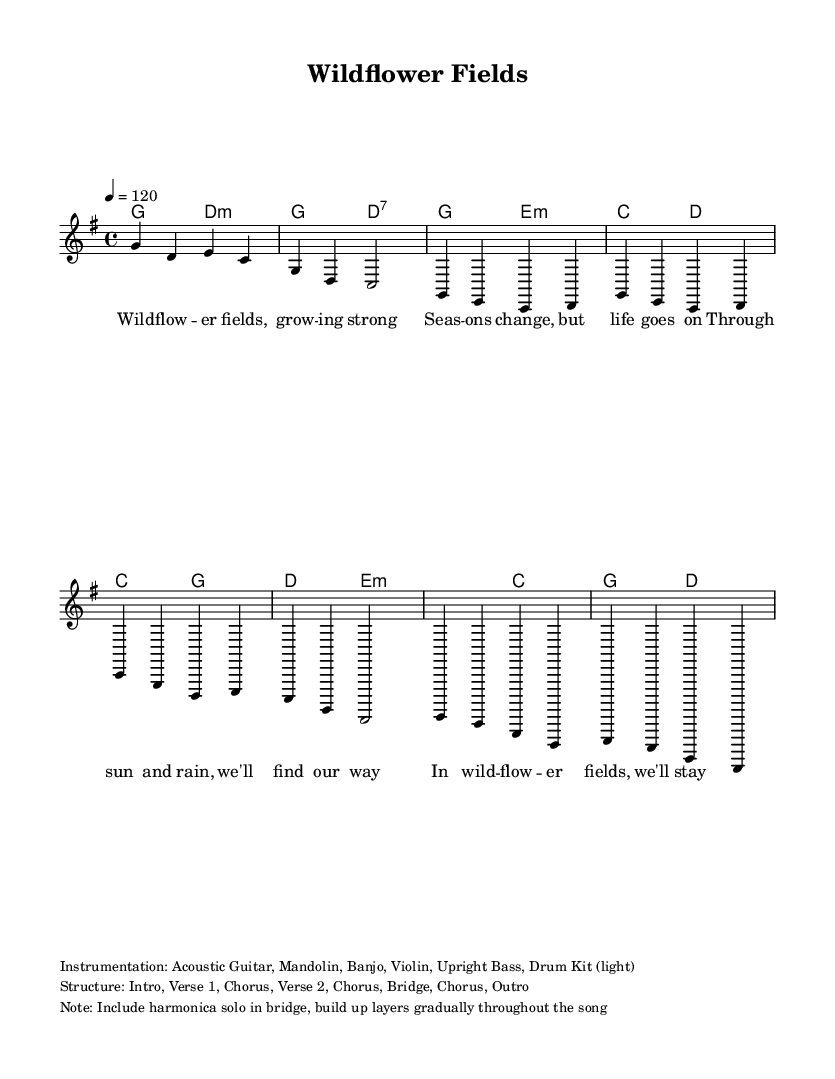What is the key signature of this music? The key signature displayed indicates G major, which has one sharp (F#). This can be identified by looking at the key signature in the left margin of the staff.
Answer: G major What is the time signature of the piece? The time signature shown is 4/4, which means there are four beats in a measure and the quarter note gets one beat. This is indicated at the beginning of the staff.
Answer: 4/4 What is the tempo marking for this song? The tempo marking is indicated as quarter note equals 120 beats per minute. This tells performers to keep a moderate and steady pace throughout the piece.
Answer: 120 How many sections does the song have? The structure of the song includes Intro, Verse 1, Chorus, Verse 2, Chorus, Bridge, Chorus, and Outro, totaling 8 distinct sections. This is summarized in the note section of the score.
Answer: 8 What instruments are indicated in the instrumentation? The instrumentation listed includes Acoustic Guitar, Mandolin, Banjo, Violin, Upright Bass, and Drum Kit (light), which can be found in the markup section.
Answer: Acoustic Guitar, Mandolin, Banjo, Violin, Upright Bass, Drum Kit (light) Which chord is played during the bridge? The bridge features the chords e minor, c major, g major, and d major, as indicated in the harmonies section, showing the progression of chords specifically for that part of the song.
Answer: e minor, c major, g major, d major 